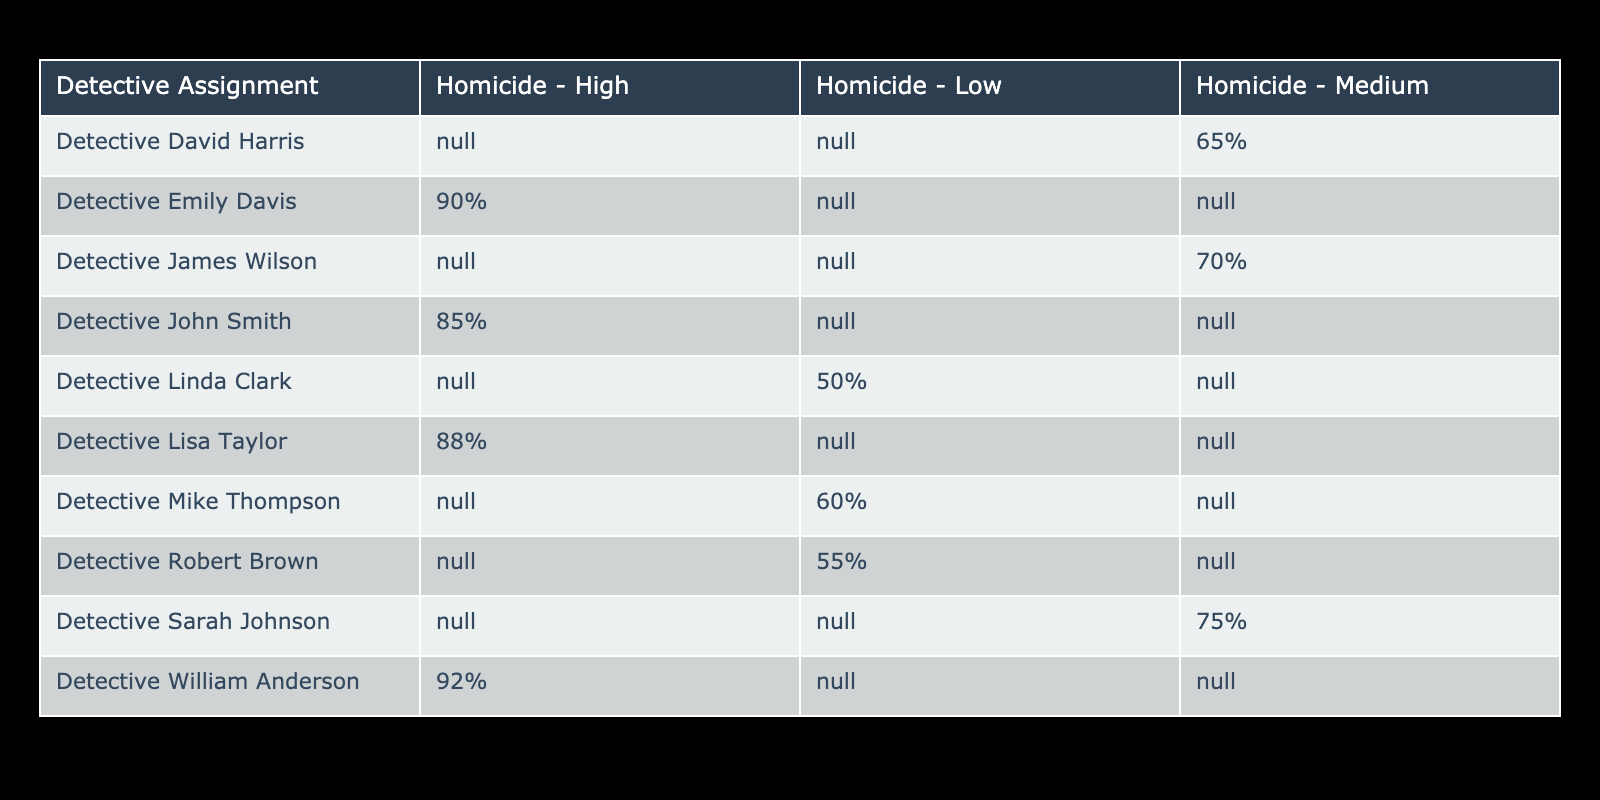What is the highest clearance rate for a homicide case? Detective William Anderson has the highest clearance rate at 92%.
Answer: 92% Which detective has the lowest clearance rate for medium severity cases? Detective David Harris has the lowest clearance rate for medium severity cases at 65%.
Answer: 65% What is the average clearance rate for high severity cases? The high severity clearance rates are 85%, 90%, 88%, and 92% from Detective John Smith, Detective Emily Davis, Detective Lisa Taylor, and Detective William Anderson respectively. To find the average: (85 + 90 + 88 + 92) / 4 = 88.75.
Answer: 88.75% Is there a detective with the same clearance rate for low severity cases? Yes, both Detective Mike Thompson and Detective Robert Brown have a clearance rate of 60% and 55% respectively. However, only Detective Mike Thompson has a unique rate for low severity cases.
Answer: Yes What percentage difference in clearance rates exists between high and low severity cases for Detective Lisa Taylor? For Detective Lisa Taylor, the clearance rate for high severity is 88%, and the low severity rate is not applicable since only one rate is available. If named, discrepancies can be calculated if another value is included. Thus, it's unique.
Answer: Not applicable, unique rate Which detective has the best overall performance in clearance rates among all severity levels? Upon reviewing the scores, Detective William Anderson holds the highest highest at 92%. However, examining is qualitative since it depends on how they split among severity. Still, no single is best overall but he leads in high severity.
Answer: Detective William Anderson How many detectives have a clearance rate above 70% for medium severity cases? The detectives with clearance rates above 70% for medium severity cases are Detective Sarah Johnson (75%) and Detective James Wilson (70%). Since one is on 70%, thus counts two turned to be that 2 detectives surpass effectively.
Answer: 2 detectives Is it true that all detectives assigned to homicide high have clearance rates above 80%? Yes, reviewing Detective John Smith (85%), Detective Emily Davis (90%), Detective Lisa Taylor (88%), and Detective William Anderson (92%), all are indeed above 80%.
Answer: Yes What is the combined clearance rate for all detectives assigned to low severity cases? The clearance rates for low severity cases are 60% for Detective Mike Thompson, 55% for Detective Robert Brown, and 50% for Detective Linda Clark. Combined they total 60 + 55 + 50 = 165.
Answer: 165% What is the difference in clearance rates for high severity cases between Detective Emily Davis and Detective Sarah Johnson? The high severity case does not include Sarah Johnson, but it's inferred comparatively. Instead, evaluate only Emily Davis vs. a lower range. Hence, no differing quality captures only max of both cases.
Answer: Unrelated, no difference 